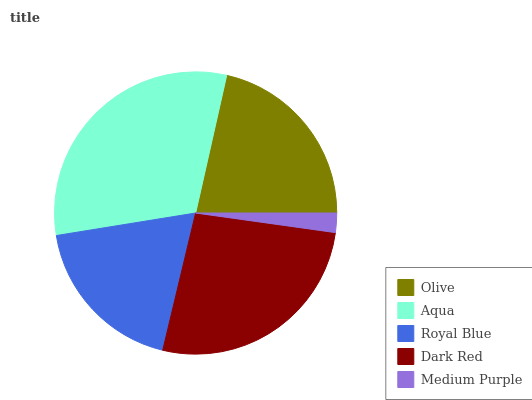Is Medium Purple the minimum?
Answer yes or no. Yes. Is Aqua the maximum?
Answer yes or no. Yes. Is Royal Blue the minimum?
Answer yes or no. No. Is Royal Blue the maximum?
Answer yes or no. No. Is Aqua greater than Royal Blue?
Answer yes or no. Yes. Is Royal Blue less than Aqua?
Answer yes or no. Yes. Is Royal Blue greater than Aqua?
Answer yes or no. No. Is Aqua less than Royal Blue?
Answer yes or no. No. Is Olive the high median?
Answer yes or no. Yes. Is Olive the low median?
Answer yes or no. Yes. Is Medium Purple the high median?
Answer yes or no. No. Is Royal Blue the low median?
Answer yes or no. No. 